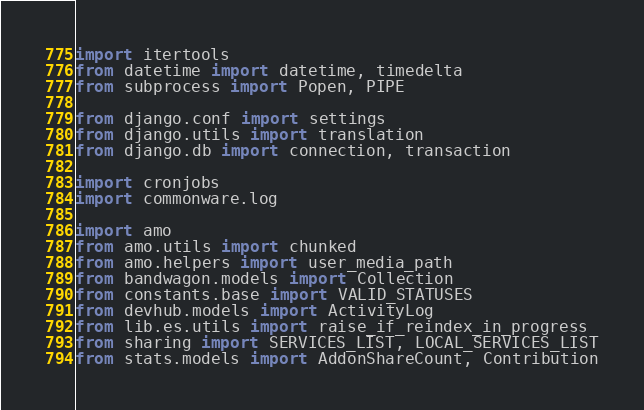<code> <loc_0><loc_0><loc_500><loc_500><_Python_>import itertools
from datetime import datetime, timedelta
from subprocess import Popen, PIPE

from django.conf import settings
from django.utils import translation
from django.db import connection, transaction

import cronjobs
import commonware.log

import amo
from amo.utils import chunked
from amo.helpers import user_media_path
from bandwagon.models import Collection
from constants.base import VALID_STATUSES
from devhub.models import ActivityLog
from lib.es.utils import raise_if_reindex_in_progress
from sharing import SERVICES_LIST, LOCAL_SERVICES_LIST
from stats.models import AddonShareCount, Contribution
</code> 